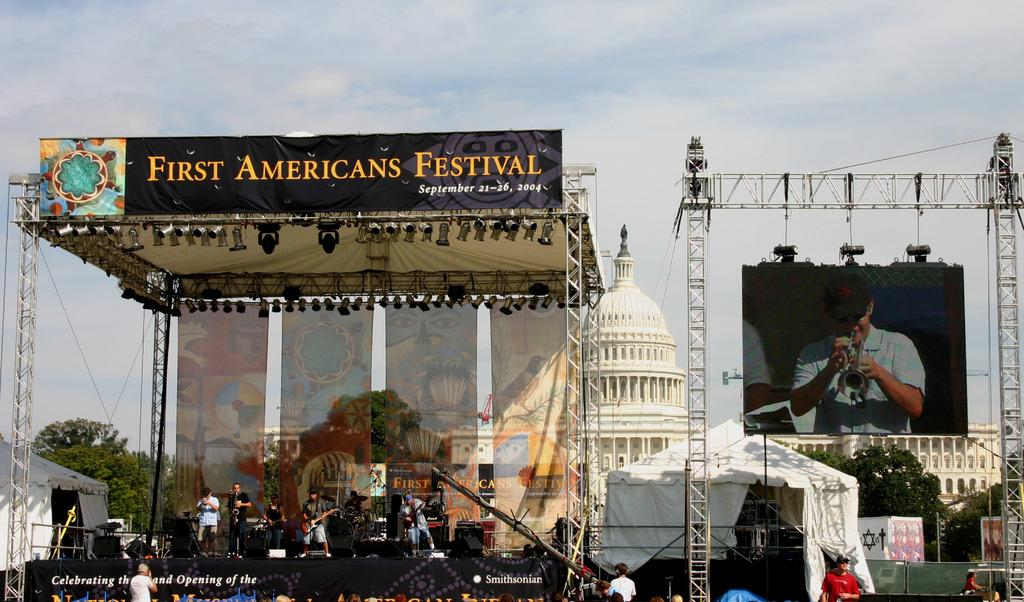<image>
Summarize the visual content of the image. First Americans Festival took place from September 21-26, 2004. 